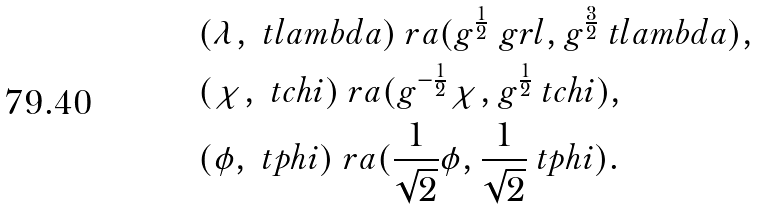Convert formula to latex. <formula><loc_0><loc_0><loc_500><loc_500>& ( \lambda , \ t l a m b d a ) \ r a ( g ^ { \frac { 1 } { 2 } } \ g r l , g ^ { \frac { 3 } { 2 } } \ t l a m b d a ) , \\ & ( \chi , \ t c h i ) \ r a ( g ^ { - \frac { 1 } { 2 } } \chi , g ^ { \frac { 1 } { 2 } } \ t c h i ) , \\ & ( \phi , \ t p h i ) \ r a ( \frac { 1 } { \sqrt { 2 } } \phi , \frac { 1 } { \sqrt { 2 } } \ t p h i ) .</formula> 